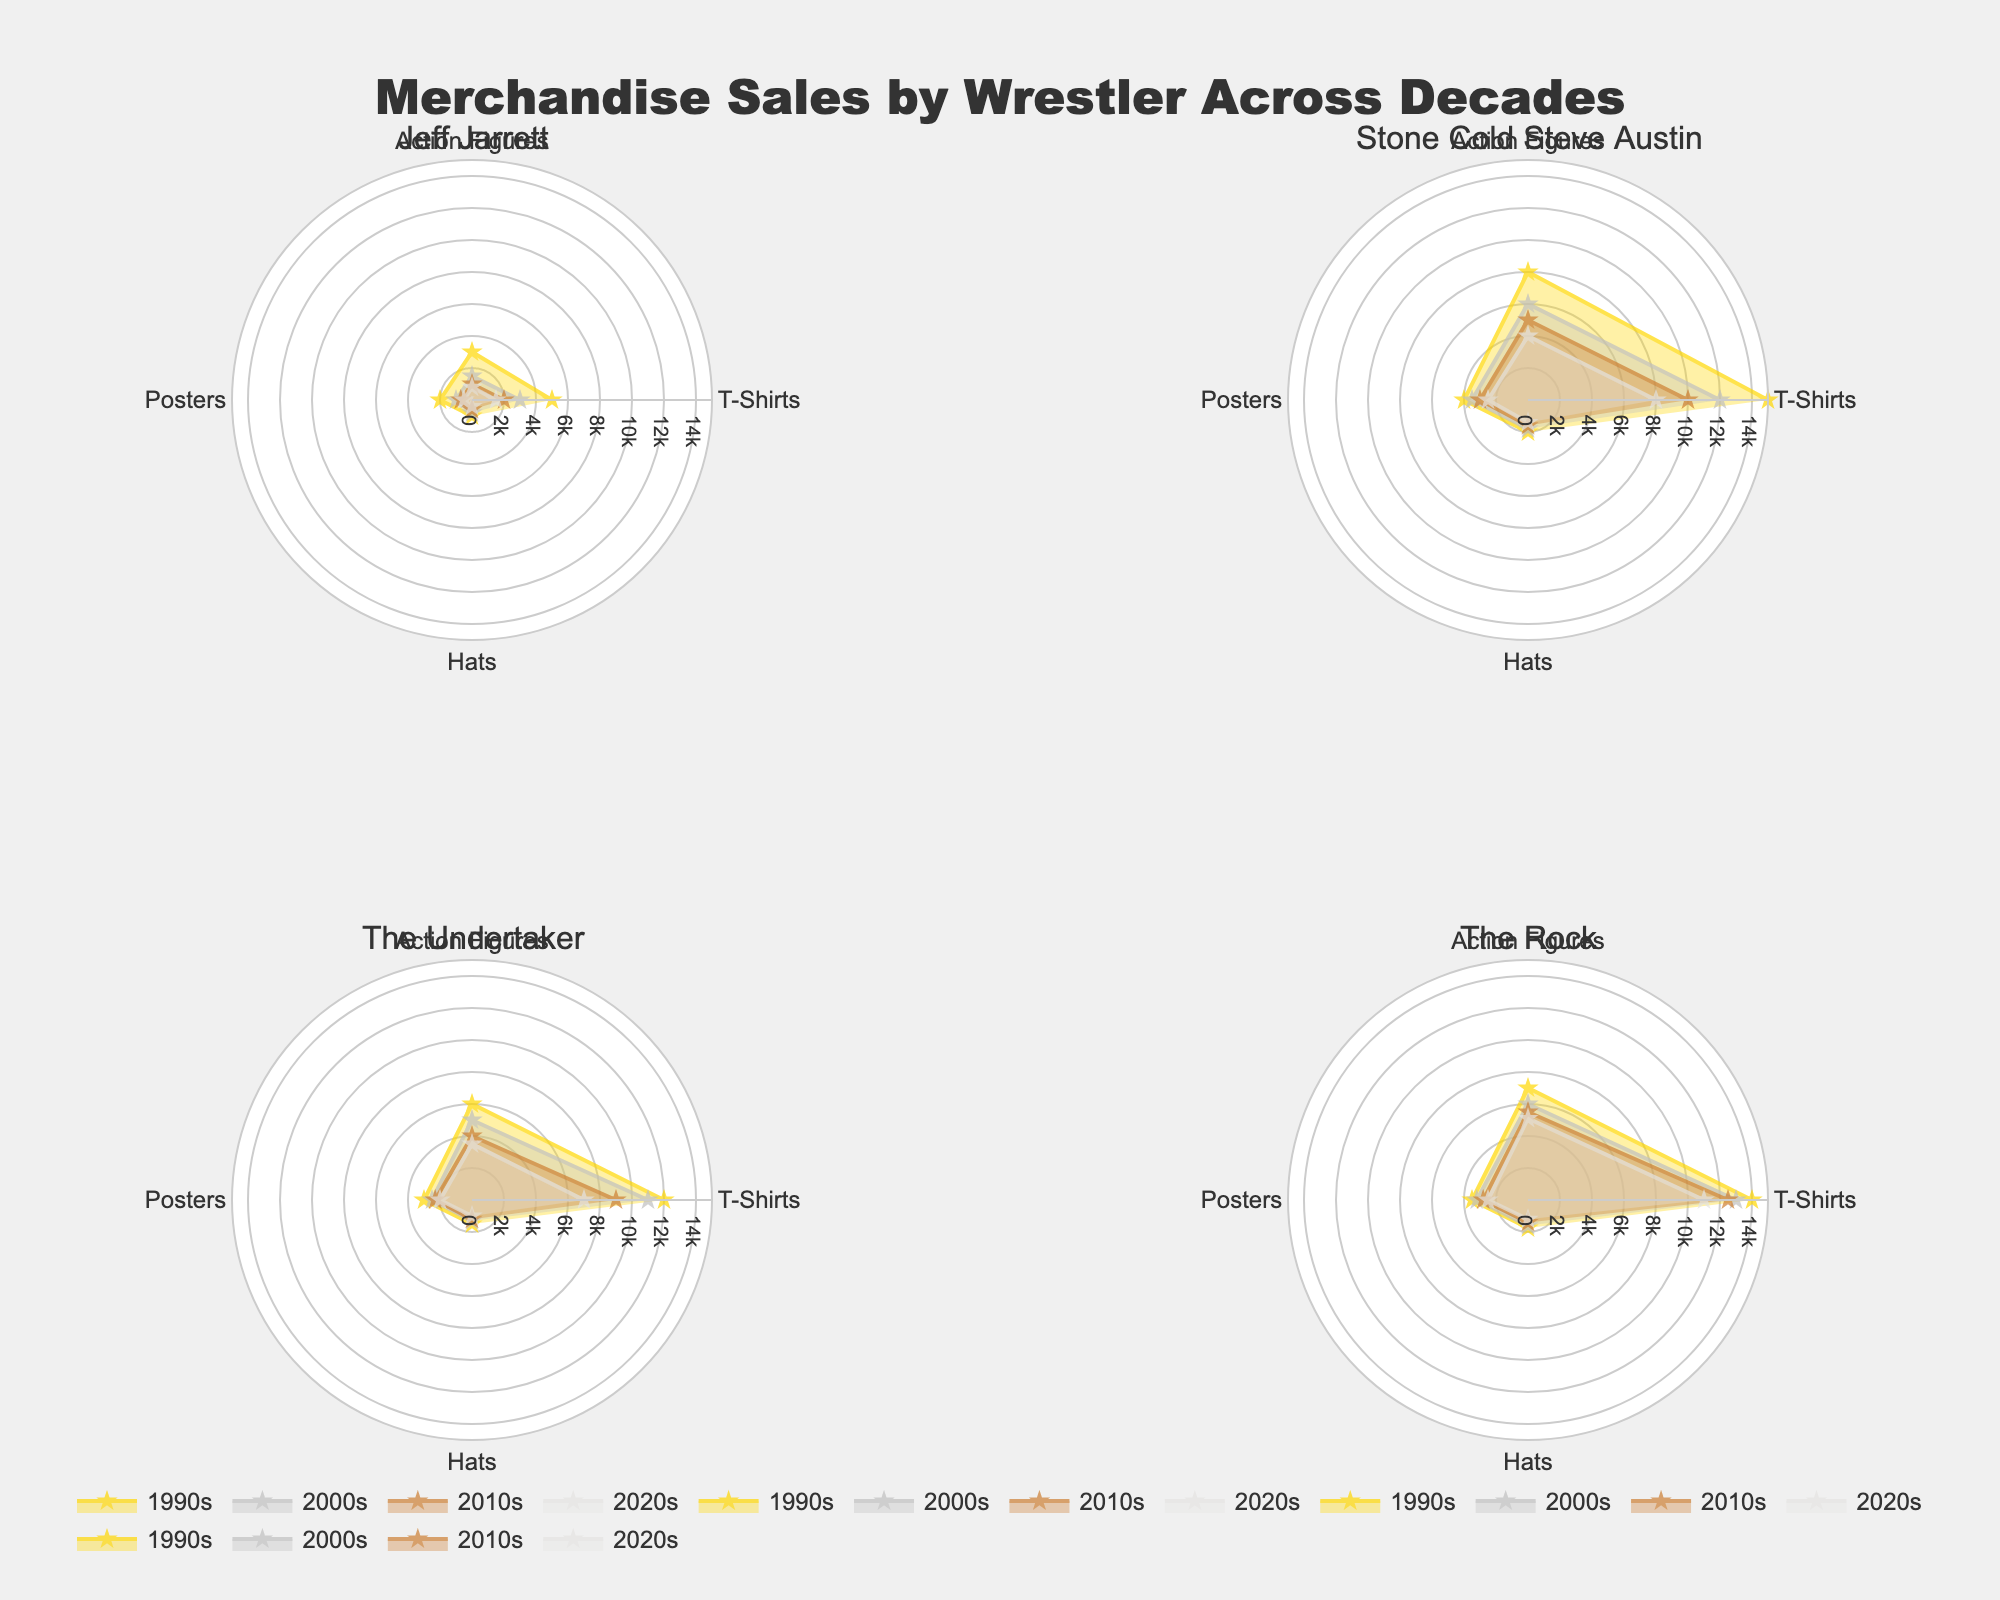What's the title of the figure? The title is displayed at the top of the figure. It summarises the visual data it's showcasing, helping viewers quickly grasp the main topic.
Answer: Merchandise Sales by Wrestler Across Decades Which product type had the highest sales for Jeff Jarrett in the 1990s? By examining the quadrant representing Jeff Jarrett in the 1990s, the radar chart peaks highest for T-Shirts compared to other product types.
Answer: T-Shirts How did the sales of action figures for Stone Cold Steve Austin change from the 1990s to the 2020s? Looking at Stone Cold Steve Austin's quadrant, the radial value for action figures in each decade shows a decreasing trend from 1990s to 2020s (8000 to 4000).
Answer: Decreased Which decade had the lowest sales for Jeff Jarrett's posters? In Jeff Jarrett's quadrant, the radar chart's lowest value for posters is in the 2020s when compared to other decades.
Answer: 2020s Compare the T-Shirt sales trend between The Rock and The Undertaker from 1990s to 2020s. By comparing The Rock's and The Undertaker's quadrants, both show a decline in T-Shirt sales, but The Rock has consistently higher values each decade.
Answer: Both declined; The Rock's sales were higher What is the average T-Shirt sales for The Undertaker across all decades? The T-Shirt sales for The Undertaker in the 1990s, 2000s, 2010s, and 2020s are summed (12000 + 11000 + 9000 + 7000 = 39000), then divided by the number of decades (4).
Answer: 9750 Which wrestler had the highest hat sales in the 2000s? By checking each wrestler's quadrant for the 2000s, Stone Cold Steve Austin has the highest radial value for hats, 1800.
Answer: Stone Cold Steve Austin Between The Rock and Stone Cold Steve Austin, who had higher poster sales in the 1990s? Comparing the 1990s' quadrants, The Rock has a radial value of 3500 for posters, while Stone Cold Steve Austin has 4000.
Answer: Stone Cold Steve Austin How do the action figure sales trends for Jeff Jarrett and The Undertaker compare from the 1990s to 2020s? Both wrestlers’ action figure sales trends show a consistent decrease over the decades. However, The Undertaker's sales are higher than Jeff Jarrett's in each decade.
Answer: Both decreased; The Undertaker's sales were higher In which decade did The Rock achieve his highest merchandise sales overall, based on the radar chart data? Observing The Rock's quadrant, the 1990s show the highest values across all product types collectively compared to other decades.
Answer: 1990s 